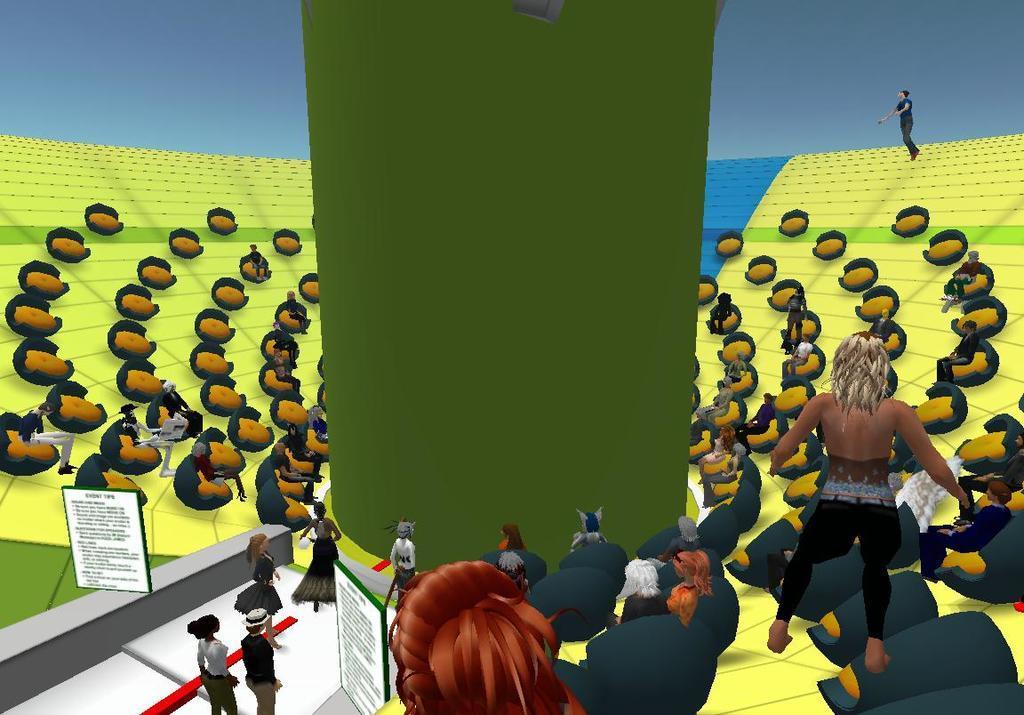Can you describe this image briefly? This is an animated image where we can see different creatures are standing here and some creatures are sitting, here we can see a green color pillar, some boards and the background of the image is in blue color. 